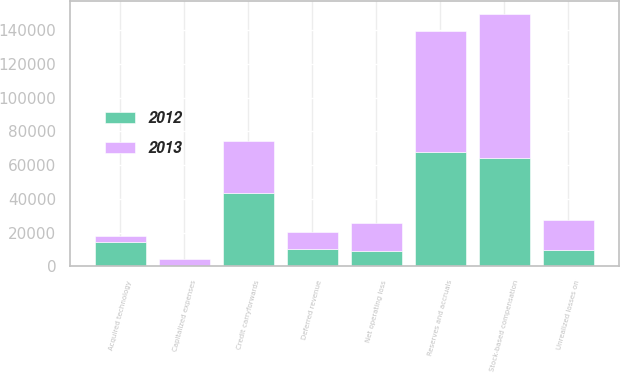<chart> <loc_0><loc_0><loc_500><loc_500><stacked_bar_chart><ecel><fcel>Acquired technology<fcel>Reserves and accruals<fcel>Deferred revenue<fcel>Unrealized losses on<fcel>Stock-based compensation<fcel>Net operating loss<fcel>Credit carryforwards<fcel>Capitalized expenses<nl><fcel>2012<fcel>14379<fcel>67753<fcel>10218<fcel>9793<fcel>64244<fcel>9222<fcel>43175<fcel>188<nl><fcel>2013<fcel>3890<fcel>71888<fcel>9941<fcel>17482<fcel>85179<fcel>16257<fcel>31172<fcel>4023<nl></chart> 